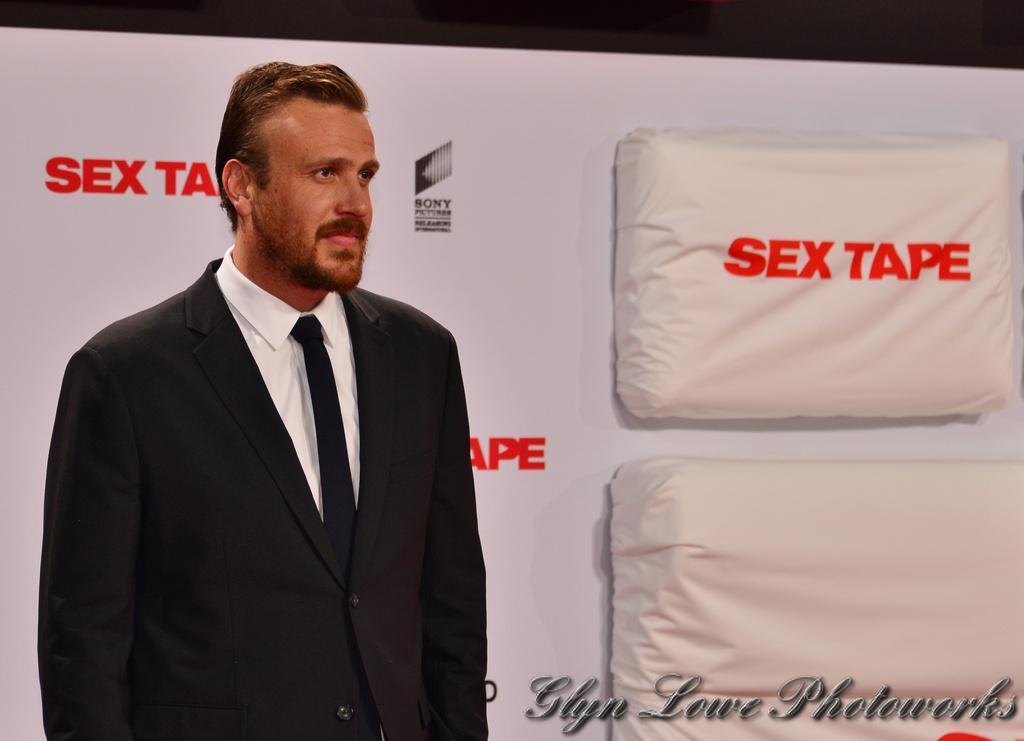Please provide a concise description of this image. In this image there is a man wearing black suit, white shirt and tie. in the background there is a banner. This is a cloth material. At the bottom few texts are there. 